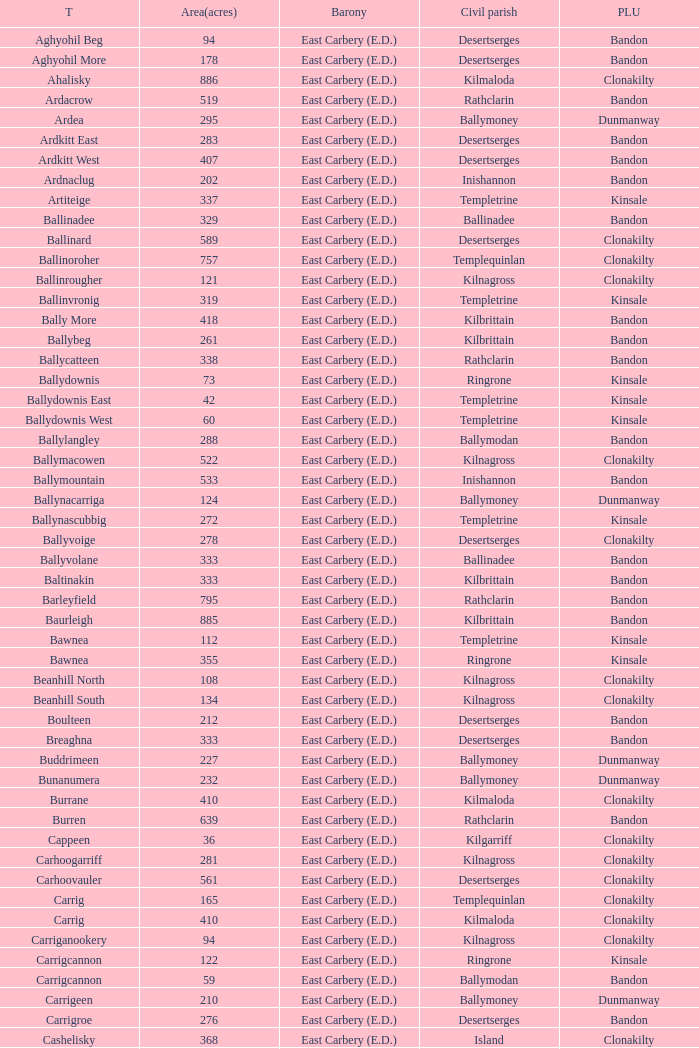What is the poor law union of the Kilmaloda townland? Clonakilty. Can you give me this table as a dict? {'header': ['T', 'Area(acres)', 'Barony', 'Civil parish', 'PLU'], 'rows': [['Aghyohil Beg', '94', 'East Carbery (E.D.)', 'Desertserges', 'Bandon'], ['Aghyohil More', '178', 'East Carbery (E.D.)', 'Desertserges', 'Bandon'], ['Ahalisky', '886', 'East Carbery (E.D.)', 'Kilmaloda', 'Clonakilty'], ['Ardacrow', '519', 'East Carbery (E.D.)', 'Rathclarin', 'Bandon'], ['Ardea', '295', 'East Carbery (E.D.)', 'Ballymoney', 'Dunmanway'], ['Ardkitt East', '283', 'East Carbery (E.D.)', 'Desertserges', 'Bandon'], ['Ardkitt West', '407', 'East Carbery (E.D.)', 'Desertserges', 'Bandon'], ['Ardnaclug', '202', 'East Carbery (E.D.)', 'Inishannon', 'Bandon'], ['Artiteige', '337', 'East Carbery (E.D.)', 'Templetrine', 'Kinsale'], ['Ballinadee', '329', 'East Carbery (E.D.)', 'Ballinadee', 'Bandon'], ['Ballinard', '589', 'East Carbery (E.D.)', 'Desertserges', 'Clonakilty'], ['Ballinoroher', '757', 'East Carbery (E.D.)', 'Templequinlan', 'Clonakilty'], ['Ballinrougher', '121', 'East Carbery (E.D.)', 'Kilnagross', 'Clonakilty'], ['Ballinvronig', '319', 'East Carbery (E.D.)', 'Templetrine', 'Kinsale'], ['Bally More', '418', 'East Carbery (E.D.)', 'Kilbrittain', 'Bandon'], ['Ballybeg', '261', 'East Carbery (E.D.)', 'Kilbrittain', 'Bandon'], ['Ballycatteen', '338', 'East Carbery (E.D.)', 'Rathclarin', 'Bandon'], ['Ballydownis', '73', 'East Carbery (E.D.)', 'Ringrone', 'Kinsale'], ['Ballydownis East', '42', 'East Carbery (E.D.)', 'Templetrine', 'Kinsale'], ['Ballydownis West', '60', 'East Carbery (E.D.)', 'Templetrine', 'Kinsale'], ['Ballylangley', '288', 'East Carbery (E.D.)', 'Ballymodan', 'Bandon'], ['Ballymacowen', '522', 'East Carbery (E.D.)', 'Kilnagross', 'Clonakilty'], ['Ballymountain', '533', 'East Carbery (E.D.)', 'Inishannon', 'Bandon'], ['Ballynacarriga', '124', 'East Carbery (E.D.)', 'Ballymoney', 'Dunmanway'], ['Ballynascubbig', '272', 'East Carbery (E.D.)', 'Templetrine', 'Kinsale'], ['Ballyvoige', '278', 'East Carbery (E.D.)', 'Desertserges', 'Clonakilty'], ['Ballyvolane', '333', 'East Carbery (E.D.)', 'Ballinadee', 'Bandon'], ['Baltinakin', '333', 'East Carbery (E.D.)', 'Kilbrittain', 'Bandon'], ['Barleyfield', '795', 'East Carbery (E.D.)', 'Rathclarin', 'Bandon'], ['Baurleigh', '885', 'East Carbery (E.D.)', 'Kilbrittain', 'Bandon'], ['Bawnea', '112', 'East Carbery (E.D.)', 'Templetrine', 'Kinsale'], ['Bawnea', '355', 'East Carbery (E.D.)', 'Ringrone', 'Kinsale'], ['Beanhill North', '108', 'East Carbery (E.D.)', 'Kilnagross', 'Clonakilty'], ['Beanhill South', '134', 'East Carbery (E.D.)', 'Kilnagross', 'Clonakilty'], ['Boulteen', '212', 'East Carbery (E.D.)', 'Desertserges', 'Bandon'], ['Breaghna', '333', 'East Carbery (E.D.)', 'Desertserges', 'Bandon'], ['Buddrimeen', '227', 'East Carbery (E.D.)', 'Ballymoney', 'Dunmanway'], ['Bunanumera', '232', 'East Carbery (E.D.)', 'Ballymoney', 'Dunmanway'], ['Burrane', '410', 'East Carbery (E.D.)', 'Kilmaloda', 'Clonakilty'], ['Burren', '639', 'East Carbery (E.D.)', 'Rathclarin', 'Bandon'], ['Cappeen', '36', 'East Carbery (E.D.)', 'Kilgarriff', 'Clonakilty'], ['Carhoogarriff', '281', 'East Carbery (E.D.)', 'Kilnagross', 'Clonakilty'], ['Carhoovauler', '561', 'East Carbery (E.D.)', 'Desertserges', 'Clonakilty'], ['Carrig', '165', 'East Carbery (E.D.)', 'Templequinlan', 'Clonakilty'], ['Carrig', '410', 'East Carbery (E.D.)', 'Kilmaloda', 'Clonakilty'], ['Carriganookery', '94', 'East Carbery (E.D.)', 'Kilnagross', 'Clonakilty'], ['Carrigcannon', '122', 'East Carbery (E.D.)', 'Ringrone', 'Kinsale'], ['Carrigcannon', '59', 'East Carbery (E.D.)', 'Ballymodan', 'Bandon'], ['Carrigeen', '210', 'East Carbery (E.D.)', 'Ballymoney', 'Dunmanway'], ['Carrigroe', '276', 'East Carbery (E.D.)', 'Desertserges', 'Bandon'], ['Cashelisky', '368', 'East Carbery (E.D.)', 'Island', 'Clonakilty'], ['Castlederry', '148', 'East Carbery (E.D.)', 'Desertserges', 'Clonakilty'], ['Clashafree', '477', 'East Carbery (E.D.)', 'Ballymodan', 'Bandon'], ['Clashreagh', '132', 'East Carbery (E.D.)', 'Templetrine', 'Kinsale'], ['Clogagh North', '173', 'East Carbery (E.D.)', 'Kilmaloda', 'Clonakilty'], ['Clogagh South', '282', 'East Carbery (E.D.)', 'Kilmaloda', 'Clonakilty'], ['Cloghane', '488', 'East Carbery (E.D.)', 'Ballinadee', 'Bandon'], ['Clogheenavodig', '70', 'East Carbery (E.D.)', 'Ballymodan', 'Bandon'], ['Cloghmacsimon', '258', 'East Carbery (E.D.)', 'Ballymodan', 'Bandon'], ['Cloheen', '360', 'East Carbery (E.D.)', 'Kilgarriff', 'Clonakilty'], ['Cloheen', '80', 'East Carbery (E.D.)', 'Island', 'Clonakilty'], ['Clonbouig', '209', 'East Carbery (E.D.)', 'Templetrine', 'Kinsale'], ['Clonbouig', '219', 'East Carbery (E.D.)', 'Ringrone', 'Kinsale'], ['Cloncouse', '241', 'East Carbery (E.D.)', 'Ballinadee', 'Bandon'], ['Clooncalla Beg', '219', 'East Carbery (E.D.)', 'Rathclarin', 'Bandon'], ['Clooncalla More', '543', 'East Carbery (E.D.)', 'Rathclarin', 'Bandon'], ['Cloonderreen', '291', 'East Carbery (E.D.)', 'Rathclarin', 'Bandon'], ['Coolmain', '450', 'East Carbery (E.D.)', 'Ringrone', 'Kinsale'], ['Corravreeda East', '258', 'East Carbery (E.D.)', 'Ballymodan', 'Bandon'], ['Corravreeda West', '169', 'East Carbery (E.D.)', 'Ballymodan', 'Bandon'], ['Cripplehill', '125', 'East Carbery (E.D.)', 'Ballymodan', 'Bandon'], ['Cripplehill', '93', 'East Carbery (E.D.)', 'Kilbrittain', 'Bandon'], ['Crohane', '91', 'East Carbery (E.D.)', 'Kilnagross', 'Clonakilty'], ['Crohane East', '108', 'East Carbery (E.D.)', 'Desertserges', 'Clonakilty'], ['Crohane West', '69', 'East Carbery (E.D.)', 'Desertserges', 'Clonakilty'], ['Crohane (or Bandon)', '204', 'East Carbery (E.D.)', 'Desertserges', 'Clonakilty'], ['Crohane (or Bandon)', '250', 'East Carbery (E.D.)', 'Kilnagross', 'Clonakilty'], ['Currabeg', '173', 'East Carbery (E.D.)', 'Ballymoney', 'Dunmanway'], ['Curraghcrowly East', '327', 'East Carbery (E.D.)', 'Ballymoney', 'Dunmanway'], ['Curraghcrowly West', '242', 'East Carbery (E.D.)', 'Ballymoney', 'Dunmanway'], ['Curraghgrane More', '110', 'East Carbery (E.D.)', 'Desert', 'Clonakilty'], ['Currane', '156', 'East Carbery (E.D.)', 'Desertserges', 'Clonakilty'], ['Curranure', '362', 'East Carbery (E.D.)', 'Inishannon', 'Bandon'], ['Currarane', '100', 'East Carbery (E.D.)', 'Templetrine', 'Kinsale'], ['Currarane', '271', 'East Carbery (E.D.)', 'Ringrone', 'Kinsale'], ['Derrigra', '177', 'East Carbery (E.D.)', 'Ballymoney', 'Dunmanway'], ['Derrigra West', '320', 'East Carbery (E.D.)', 'Ballymoney', 'Dunmanway'], ['Derry', '140', 'East Carbery (E.D.)', 'Desertserges', 'Clonakilty'], ['Derrymeeleen', '441', 'East Carbery (E.D.)', 'Desertserges', 'Clonakilty'], ['Desert', '339', 'East Carbery (E.D.)', 'Desert', 'Clonakilty'], ['Drombofinny', '86', 'East Carbery (E.D.)', 'Desertserges', 'Bandon'], ['Dromgarriff', '335', 'East Carbery (E.D.)', 'Kilmaloda', 'Clonakilty'], ['Dromgarriff East', '385', 'East Carbery (E.D.)', 'Kilnagross', 'Clonakilty'], ['Dromgarriff West', '138', 'East Carbery (E.D.)', 'Kilnagross', 'Clonakilty'], ['Dromkeen', '673', 'East Carbery (E.D.)', 'Inishannon', 'Bandon'], ['Edencurra', '516', 'East Carbery (E.D.)', 'Ballymoney', 'Dunmanway'], ['Farran', '502', 'East Carbery (E.D.)', 'Kilmaloda', 'Clonakilty'], ['Farranagow', '99', 'East Carbery (E.D.)', 'Inishannon', 'Bandon'], ['Farrannagark', '290', 'East Carbery (E.D.)', 'Rathclarin', 'Bandon'], ['Farrannasheshery', '304', 'East Carbery (E.D.)', 'Desertserges', 'Bandon'], ['Fourcuil', '125', 'East Carbery (E.D.)', 'Kilgarriff', 'Clonakilty'], ['Fourcuil', '244', 'East Carbery (E.D.)', 'Templebryan', 'Clonakilty'], ['Garranbeg', '170', 'East Carbery (E.D.)', 'Ballymodan', 'Bandon'], ['Garraneanasig', '270', 'East Carbery (E.D.)', 'Ringrone', 'Kinsale'], ['Garraneard', '276', 'East Carbery (E.D.)', 'Kilnagross', 'Clonakilty'], ['Garranecore', '144', 'East Carbery (E.D.)', 'Templebryan', 'Clonakilty'], ['Garranecore', '186', 'East Carbery (E.D.)', 'Kilgarriff', 'Clonakilty'], ['Garranefeen', '478', 'East Carbery (E.D.)', 'Rathclarin', 'Bandon'], ['Garraneishal', '121', 'East Carbery (E.D.)', 'Kilnagross', 'Clonakilty'], ['Garranelahan', '126', 'East Carbery (E.D.)', 'Desertserges', 'Bandon'], ['Garranereagh', '398', 'East Carbery (E.D.)', 'Ringrone', 'Kinsale'], ['Garranes', '416', 'East Carbery (E.D.)', 'Desertserges', 'Clonakilty'], ['Garranure', '436', 'East Carbery (E.D.)', 'Ballymoney', 'Dunmanway'], ['Garryndruig', '856', 'East Carbery (E.D.)', 'Rathclarin', 'Bandon'], ['Glan', '194', 'East Carbery (E.D.)', 'Ballymoney', 'Dunmanway'], ['Glanavaud', '98', 'East Carbery (E.D.)', 'Ringrone', 'Kinsale'], ['Glanavirane', '107', 'East Carbery (E.D.)', 'Templetrine', 'Kinsale'], ['Glanavirane', '91', 'East Carbery (E.D.)', 'Ringrone', 'Kinsale'], ['Glanduff', '464', 'East Carbery (E.D.)', 'Rathclarin', 'Bandon'], ['Grillagh', '136', 'East Carbery (E.D.)', 'Kilnagross', 'Clonakilty'], ['Grillagh', '316', 'East Carbery (E.D.)', 'Ballymoney', 'Dunmanway'], ['Hacketstown', '182', 'East Carbery (E.D.)', 'Templetrine', 'Kinsale'], ['Inchafune', '871', 'East Carbery (E.D.)', 'Ballymoney', 'Dunmanway'], ['Inchydoney Island', '474', 'East Carbery (E.D.)', 'Island', 'Clonakilty'], ['Kilbeloge', '216', 'East Carbery (E.D.)', 'Desertserges', 'Clonakilty'], ['Kilbree', '284', 'East Carbery (E.D.)', 'Island', 'Clonakilty'], ['Kilbrittain', '483', 'East Carbery (E.D.)', 'Kilbrittain', 'Bandon'], ['Kilcaskan', '221', 'East Carbery (E.D.)', 'Ballymoney', 'Dunmanway'], ['Kildarra', '463', 'East Carbery (E.D.)', 'Ballinadee', 'Bandon'], ['Kilgarriff', '835', 'East Carbery (E.D.)', 'Kilgarriff', 'Clonakilty'], ['Kilgobbin', '1263', 'East Carbery (E.D.)', 'Ballinadee', 'Bandon'], ['Kill North', '136', 'East Carbery (E.D.)', 'Desertserges', 'Clonakilty'], ['Kill South', '139', 'East Carbery (E.D.)', 'Desertserges', 'Clonakilty'], ['Killanamaul', '220', 'East Carbery (E.D.)', 'Kilbrittain', 'Bandon'], ['Killaneetig', '342', 'East Carbery (E.D.)', 'Ballinadee', 'Bandon'], ['Killavarrig', '708', 'East Carbery (E.D.)', 'Timoleague', 'Clonakilty'], ['Killeen', '309', 'East Carbery (E.D.)', 'Desertserges', 'Clonakilty'], ['Killeens', '132', 'East Carbery (E.D.)', 'Templetrine', 'Kinsale'], ['Kilmacsimon', '219', 'East Carbery (E.D.)', 'Ballinadee', 'Bandon'], ['Kilmaloda', '634', 'East Carbery (E.D.)', 'Kilmaloda', 'Clonakilty'], ['Kilmoylerane North', '306', 'East Carbery (E.D.)', 'Desertserges', 'Clonakilty'], ['Kilmoylerane South', '324', 'East Carbery (E.D.)', 'Desertserges', 'Clonakilty'], ['Kilnameela', '397', 'East Carbery (E.D.)', 'Desertserges', 'Bandon'], ['Kilrush', '189', 'East Carbery (E.D.)', 'Desertserges', 'Bandon'], ['Kilshinahan', '528', 'East Carbery (E.D.)', 'Kilbrittain', 'Bandon'], ['Kilvinane', '199', 'East Carbery (E.D.)', 'Ballymoney', 'Dunmanway'], ['Kilvurra', '356', 'East Carbery (E.D.)', 'Ballymoney', 'Dunmanway'], ['Knockacullen', '381', 'East Carbery (E.D.)', 'Desertserges', 'Clonakilty'], ['Knockaneady', '393', 'East Carbery (E.D.)', 'Ballymoney', 'Dunmanway'], ['Knockaneroe', '127', 'East Carbery (E.D.)', 'Templetrine', 'Kinsale'], ['Knockanreagh', '139', 'East Carbery (E.D.)', 'Ballymodan', 'Bandon'], ['Knockbrown', '312', 'East Carbery (E.D.)', 'Kilbrittain', 'Bandon'], ['Knockbrown', '510', 'East Carbery (E.D.)', 'Kilmaloda', 'Bandon'], ['Knockeenbwee Lower', '213', 'East Carbery (E.D.)', 'Dromdaleague', 'Skibbereen'], ['Knockeenbwee Upper', '229', 'East Carbery (E.D.)', 'Dromdaleague', 'Skibbereen'], ['Knockeencon', '108', 'East Carbery (E.D.)', 'Tullagh', 'Skibbereen'], ['Knockmacool', '241', 'East Carbery (E.D.)', 'Desertserges', 'Bandon'], ['Knocknacurra', '422', 'East Carbery (E.D.)', 'Ballinadee', 'Bandon'], ['Knocknagappul', '507', 'East Carbery (E.D.)', 'Ballinadee', 'Bandon'], ['Knocknanuss', '394', 'East Carbery (E.D.)', 'Desertserges', 'Clonakilty'], ['Knocknastooka', '118', 'East Carbery (E.D.)', 'Desertserges', 'Bandon'], ['Knockroe', '601', 'East Carbery (E.D.)', 'Inishannon', 'Bandon'], ['Knocks', '540', 'East Carbery (E.D.)', 'Desertserges', 'Clonakilty'], ['Knockskagh', '489', 'East Carbery (E.D.)', 'Kilgarriff', 'Clonakilty'], ['Knoppoge', '567', 'East Carbery (E.D.)', 'Kilbrittain', 'Bandon'], ['Lackanalooha', '209', 'East Carbery (E.D.)', 'Kilnagross', 'Clonakilty'], ['Lackenagobidane', '48', 'East Carbery (E.D.)', 'Island', 'Clonakilty'], ['Lisbehegh', '255', 'East Carbery (E.D.)', 'Desertserges', 'Clonakilty'], ['Lisheen', '44', 'East Carbery (E.D.)', 'Templetrine', 'Kinsale'], ['Lisheenaleen', '267', 'East Carbery (E.D.)', 'Rathclarin', 'Bandon'], ['Lisnacunna', '529', 'East Carbery (E.D.)', 'Desertserges', 'Bandon'], ['Lisroe', '91', 'East Carbery (E.D.)', 'Kilgarriff', 'Clonakilty'], ['Lissaphooca', '513', 'East Carbery (E.D.)', 'Ballymodan', 'Bandon'], ['Lisselane', '429', 'East Carbery (E.D.)', 'Kilnagross', 'Clonakilty'], ['Madame', '273', 'East Carbery (E.D.)', 'Kilmaloda', 'Clonakilty'], ['Madame', '41', 'East Carbery (E.D.)', 'Kilnagross', 'Clonakilty'], ['Maulbrack East', '100', 'East Carbery (E.D.)', 'Desertserges', 'Bandon'], ['Maulbrack West', '242', 'East Carbery (E.D.)', 'Desertserges', 'Bandon'], ['Maulmane', '219', 'East Carbery (E.D.)', 'Kilbrittain', 'Bandon'], ['Maulnageragh', '135', 'East Carbery (E.D.)', 'Kilnagross', 'Clonakilty'], ['Maulnarouga North', '81', 'East Carbery (E.D.)', 'Desertserges', 'Bandon'], ['Maulnarouga South', '374', 'East Carbery (E.D.)', 'Desertserges', 'Bandon'], ['Maulnaskehy', '14', 'East Carbery (E.D.)', 'Kilgarriff', 'Clonakilty'], ['Maulrour', '244', 'East Carbery (E.D.)', 'Desertserges', 'Clonakilty'], ['Maulrour', '340', 'East Carbery (E.D.)', 'Kilmaloda', 'Clonakilty'], ['Maulskinlahane', '245', 'East Carbery (E.D.)', 'Kilbrittain', 'Bandon'], ['Miles', '268', 'East Carbery (E.D.)', 'Kilgarriff', 'Clonakilty'], ['Moanarone', '235', 'East Carbery (E.D.)', 'Ballymodan', 'Bandon'], ['Monteen', '589', 'East Carbery (E.D.)', 'Kilmaloda', 'Clonakilty'], ['Phale Lower', '287', 'East Carbery (E.D.)', 'Ballymoney', 'Dunmanway'], ['Phale Upper', '234', 'East Carbery (E.D.)', 'Ballymoney', 'Dunmanway'], ['Ratharoon East', '810', 'East Carbery (E.D.)', 'Ballinadee', 'Bandon'], ['Ratharoon West', '383', 'East Carbery (E.D.)', 'Ballinadee', 'Bandon'], ['Rathdrought', '1242', 'East Carbery (E.D.)', 'Ballinadee', 'Bandon'], ['Reengarrigeen', '560', 'East Carbery (E.D.)', 'Kilmaloda', 'Clonakilty'], ['Reenroe', '123', 'East Carbery (E.D.)', 'Kilgarriff', 'Clonakilty'], ['Rochestown', '104', 'East Carbery (E.D.)', 'Templetrine', 'Kinsale'], ['Rockfort', '308', 'East Carbery (E.D.)', 'Brinny', 'Bandon'], ['Rockhouse', '82', 'East Carbery (E.D.)', 'Ballinadee', 'Bandon'], ['Scartagh', '186', 'East Carbery (E.D.)', 'Kilgarriff', 'Clonakilty'], ['Shanakill', '197', 'East Carbery (E.D.)', 'Rathclarin', 'Bandon'], ['Shanaway East', '386', 'East Carbery (E.D.)', 'Ballymoney', 'Dunmanway'], ['Shanaway Middle', '296', 'East Carbery (E.D.)', 'Ballymoney', 'Dunmanway'], ['Shanaway West', '266', 'East Carbery (E.D.)', 'Ballymoney', 'Dunmanway'], ['Skeaf', '452', 'East Carbery (E.D.)', 'Kilmaloda', 'Clonakilty'], ['Skeaf East', '371', 'East Carbery (E.D.)', 'Kilmaloda', 'Clonakilty'], ['Skeaf West', '477', 'East Carbery (E.D.)', 'Kilmaloda', 'Clonakilty'], ['Skevanish', '359', 'East Carbery (E.D.)', 'Inishannon', 'Bandon'], ['Steilaneigh', '42', 'East Carbery (E.D.)', 'Templetrine', 'Kinsale'], ['Tawnies Lower', '238', 'East Carbery (E.D.)', 'Kilgarriff', 'Clonakilty'], ['Tawnies Upper', '321', 'East Carbery (E.D.)', 'Kilgarriff', 'Clonakilty'], ['Templebryan North', '436', 'East Carbery (E.D.)', 'Templebryan', 'Clonakilty'], ['Templebryan South', '363', 'East Carbery (E.D.)', 'Templebryan', 'Clonakilty'], ['Tullig', '135', 'East Carbery (E.D.)', 'Kilmaloda', 'Clonakilty'], ['Tullyland', '348', 'East Carbery (E.D.)', 'Ballymodan', 'Bandon'], ['Tullyland', '506', 'East Carbery (E.D.)', 'Ballinadee', 'Bandon'], ['Tullymurrihy', '665', 'East Carbery (E.D.)', 'Desertserges', 'Bandon'], ['Youghals', '109', 'East Carbery (E.D.)', 'Island', 'Clonakilty']]} 